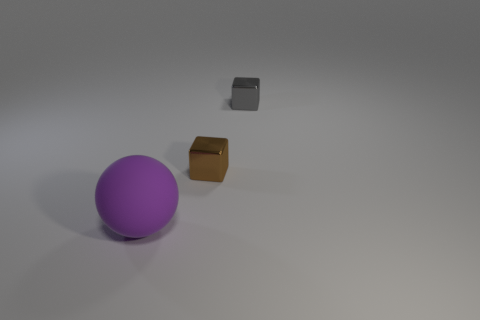Add 2 tiny gray blocks. How many objects exist? 5 Subtract all spheres. How many objects are left? 2 Add 2 large things. How many large things are left? 3 Add 1 metallic blocks. How many metallic blocks exist? 3 Subtract 0 brown cylinders. How many objects are left? 3 Subtract all green cylinders. Subtract all shiny cubes. How many objects are left? 1 